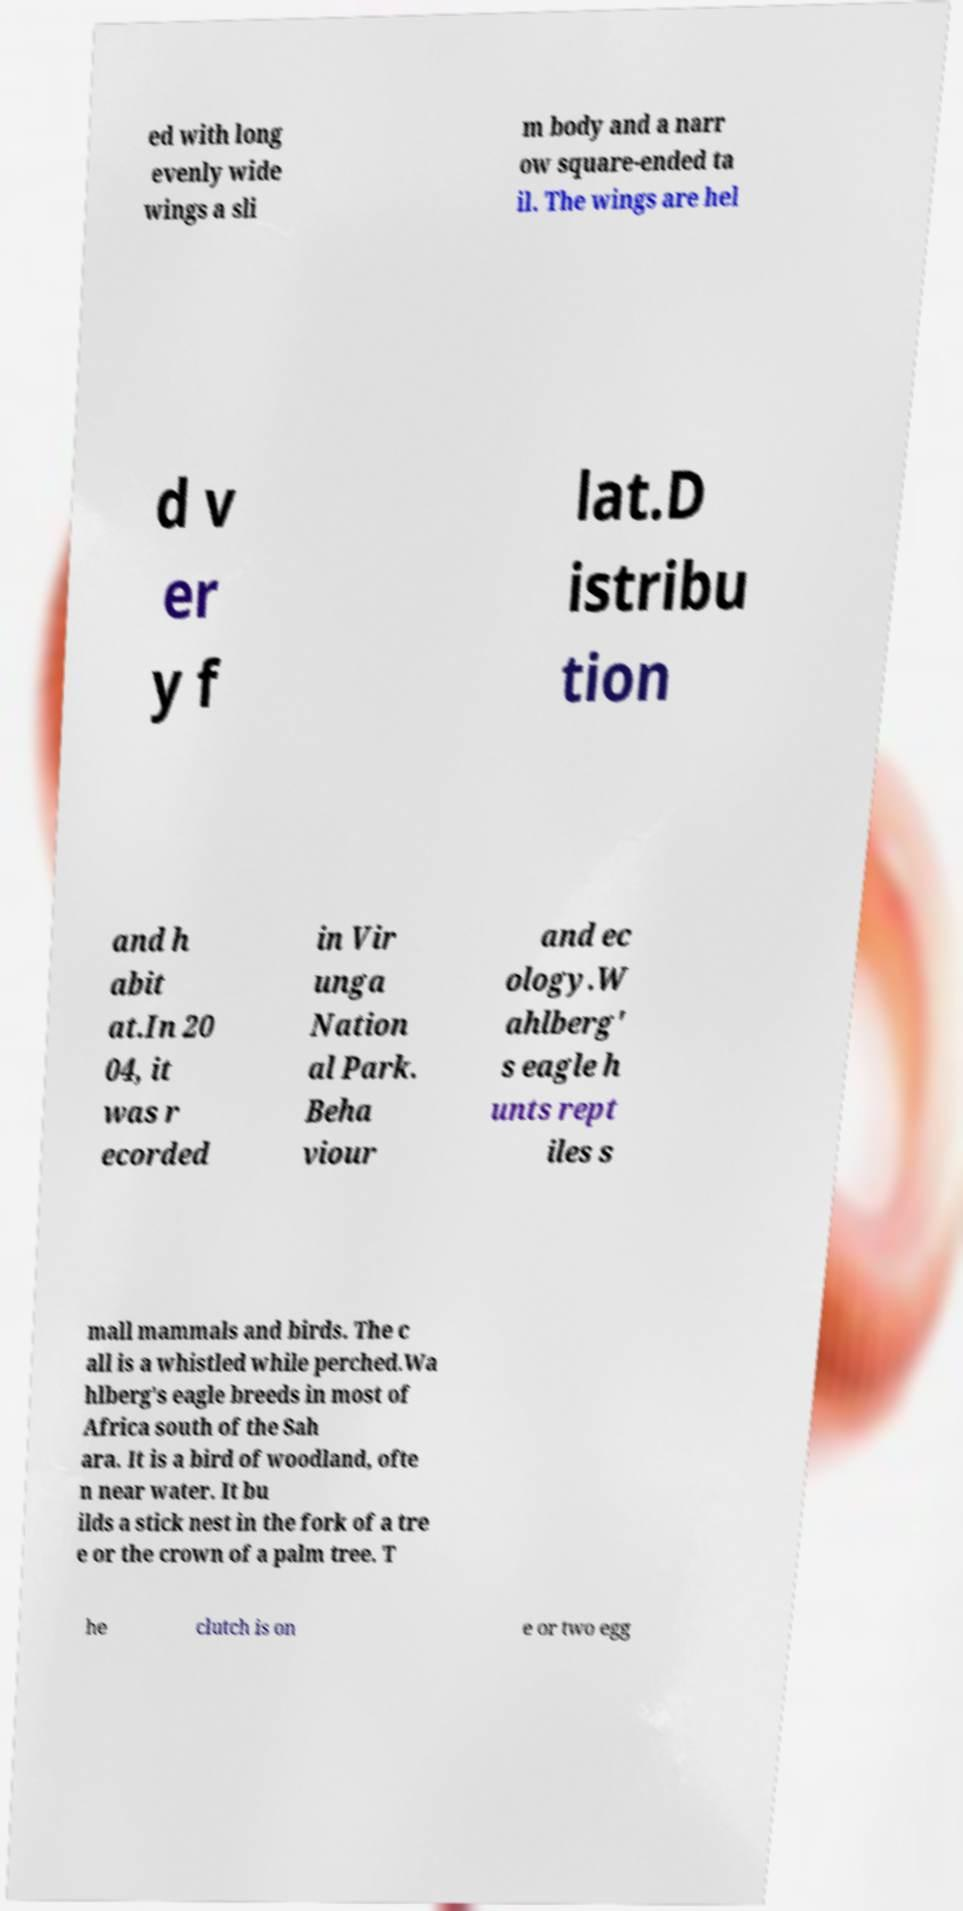Please identify and transcribe the text found in this image. ed with long evenly wide wings a sli m body and a narr ow square-ended ta il. The wings are hel d v er y f lat.D istribu tion and h abit at.In 20 04, it was r ecorded in Vir unga Nation al Park. Beha viour and ec ology.W ahlberg' s eagle h unts rept iles s mall mammals and birds. The c all is a whistled while perched.Wa hlberg's eagle breeds in most of Africa south of the Sah ara. It is a bird of woodland, ofte n near water. It bu ilds a stick nest in the fork of a tre e or the crown of a palm tree. T he clutch is on e or two egg 